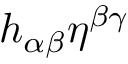Convert formula to latex. <formula><loc_0><loc_0><loc_500><loc_500>h _ { \alpha \beta } \eta ^ { \beta \gamma }</formula> 